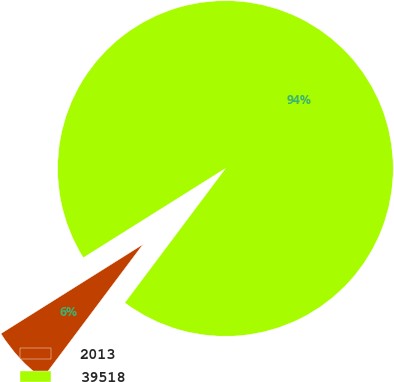<chart> <loc_0><loc_0><loc_500><loc_500><pie_chart><fcel>2013<fcel>39518<nl><fcel>5.84%<fcel>94.16%<nl></chart> 